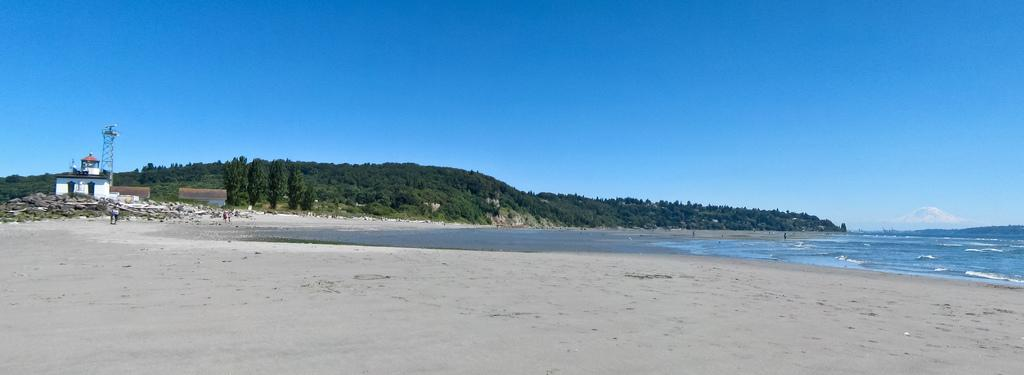Where are the people located in the image? The people are at the sea shore in the image. What type of natural landscape can be seen in the image? There are mountains covered with trees in the image. What body of water is visible in the image? There is an ocean visible in the image. What type of structures can be seen in the image? There are houses and a tower in the image. What type of terrain is present at the sea shore? There are stones in the image. What is visible in the sky-wise in the image? The sky is visible in the image. What type of plastic is being used by the army in the image? There is no army or plastic present in the image. What emotion is displayed by the people in the image? The image does not provide information about the emotions of the people in the image, so we cannot determine if they are feeling disgust or any other emotion. 